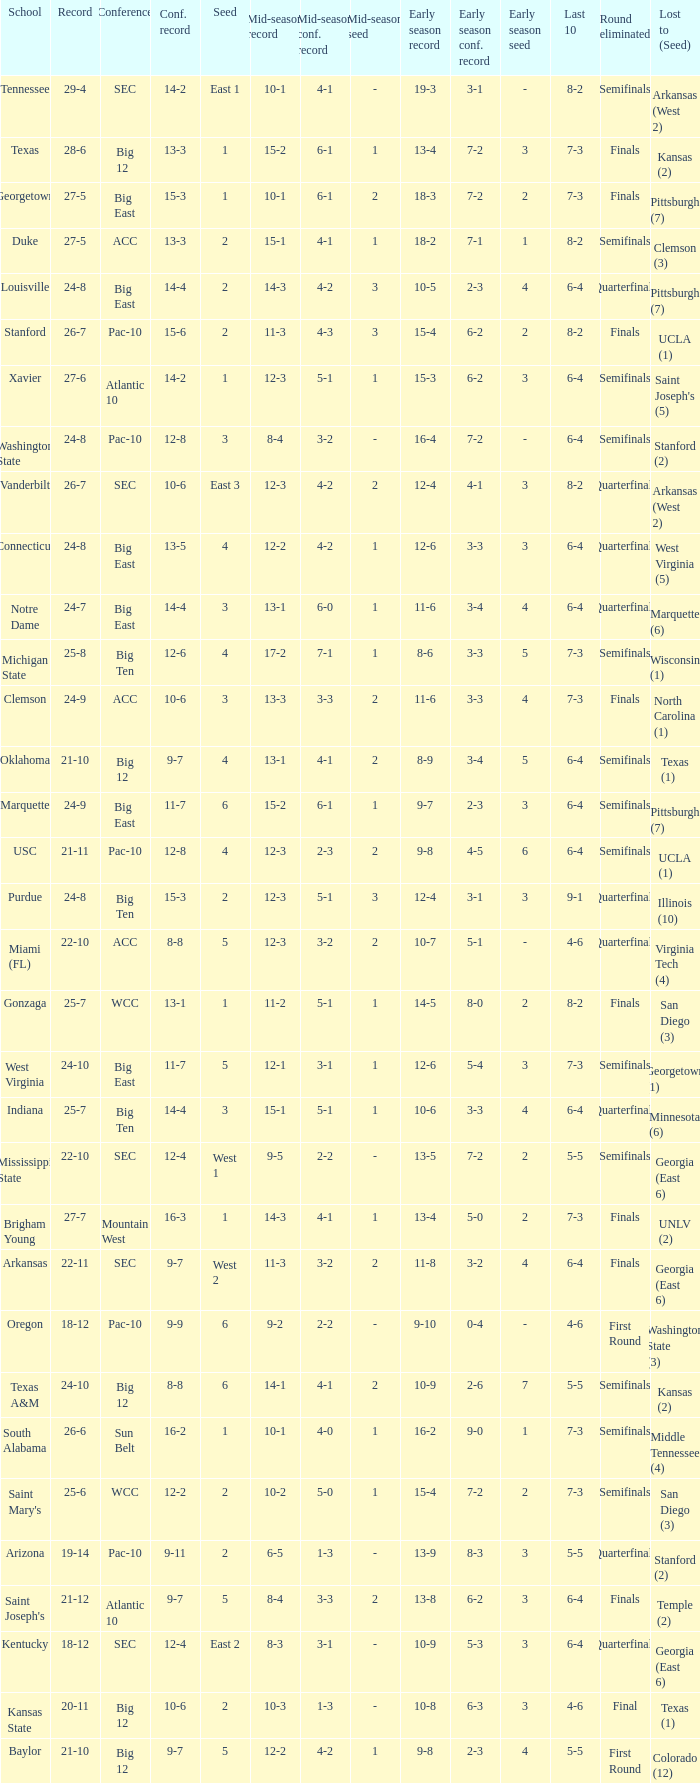Name the round eliminated where conference record is 12-6 Semifinals. 